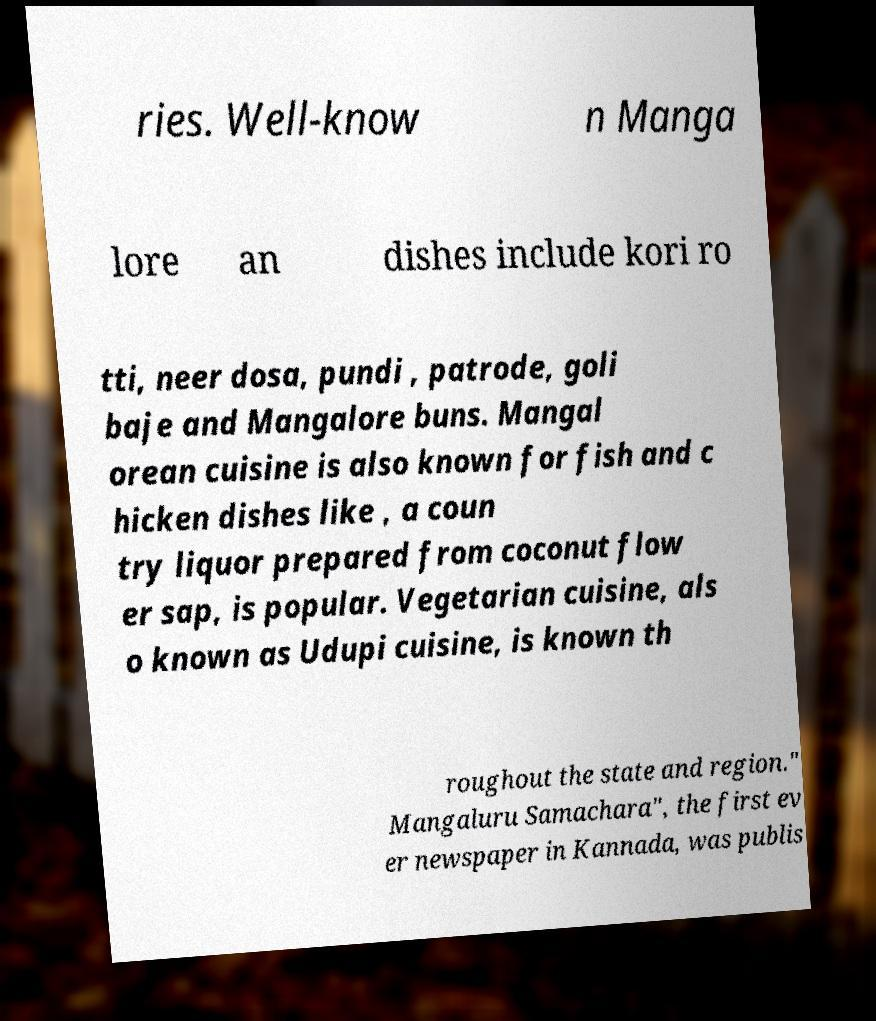Could you assist in decoding the text presented in this image and type it out clearly? ries. Well-know n Manga lore an dishes include kori ro tti, neer dosa, pundi , patrode, goli baje and Mangalore buns. Mangal orean cuisine is also known for fish and c hicken dishes like , a coun try liquor prepared from coconut flow er sap, is popular. Vegetarian cuisine, als o known as Udupi cuisine, is known th roughout the state and region." Mangaluru Samachara", the first ev er newspaper in Kannada, was publis 